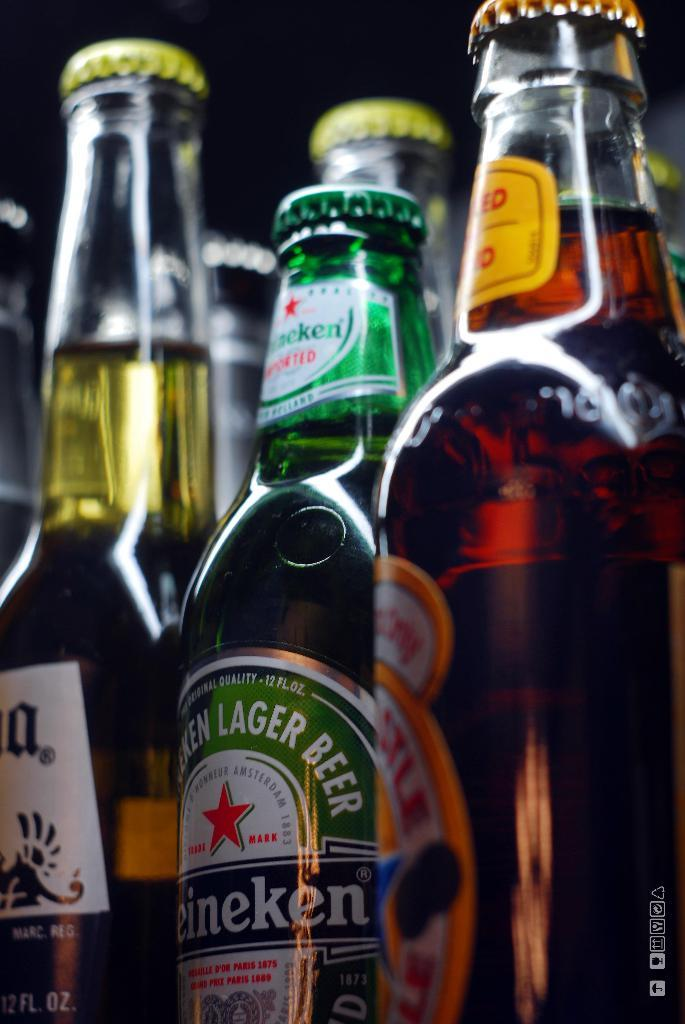Provide a one-sentence caption for the provided image. A row of unopened beer bottles including Heineken. 